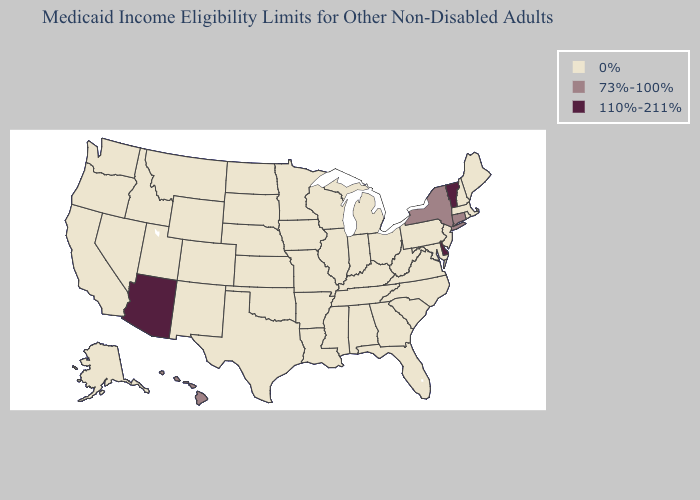Name the states that have a value in the range 110%-211%?
Short answer required. Arizona, Delaware, Vermont. Does Texas have the highest value in the USA?
Short answer required. No. Does Vermont have the lowest value in the USA?
Quick response, please. No. Name the states that have a value in the range 73%-100%?
Concise answer only. Connecticut, Hawaii, New York. What is the value of Rhode Island?
Write a very short answer. 0%. Does the map have missing data?
Give a very brief answer. No. Name the states that have a value in the range 110%-211%?
Keep it brief. Arizona, Delaware, Vermont. What is the value of Nevada?
Short answer required. 0%. Which states have the lowest value in the South?
Concise answer only. Alabama, Arkansas, Florida, Georgia, Kentucky, Louisiana, Maryland, Mississippi, North Carolina, Oklahoma, South Carolina, Tennessee, Texas, Virginia, West Virginia. What is the highest value in the South ?
Give a very brief answer. 110%-211%. Which states have the lowest value in the USA?
Concise answer only. Alabama, Alaska, Arkansas, California, Colorado, Florida, Georgia, Idaho, Illinois, Indiana, Iowa, Kansas, Kentucky, Louisiana, Maine, Maryland, Massachusetts, Michigan, Minnesota, Mississippi, Missouri, Montana, Nebraska, Nevada, New Hampshire, New Jersey, New Mexico, North Carolina, North Dakota, Ohio, Oklahoma, Oregon, Pennsylvania, Rhode Island, South Carolina, South Dakota, Tennessee, Texas, Utah, Virginia, Washington, West Virginia, Wisconsin, Wyoming. Name the states that have a value in the range 110%-211%?
Give a very brief answer. Arizona, Delaware, Vermont. What is the highest value in states that border New Mexico?
Write a very short answer. 110%-211%. Which states hav the highest value in the Northeast?
Write a very short answer. Vermont. 